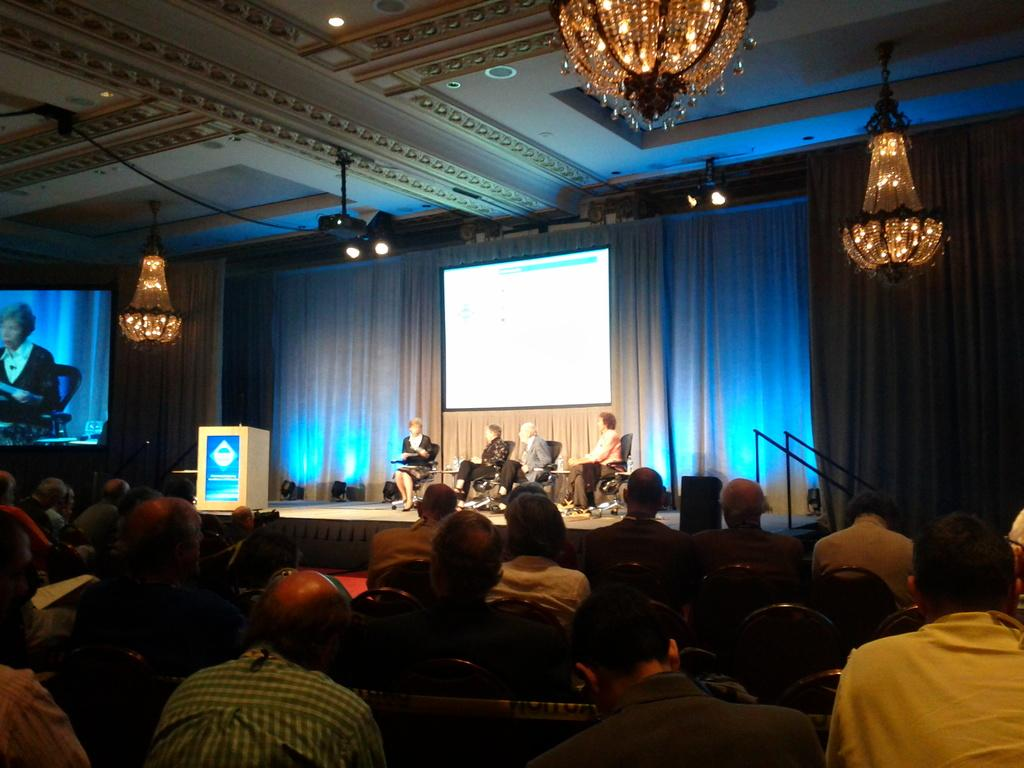How many people are in the image? There is a group of people in the image. What are some of the people doing in the image? Some people are sitting on chairs, while others are on stage. What can be seen on stage in the image? There is a podium in the image. What type of lighting is present in the image? There are lights in the image. What type of display devices are present in the image? There are screens in the image. What type of decorative element is present in the image? There is a chandelier in the image. What type of audio equipment is present in the image? There is a speaker in the image. What type of structure is present in the image? There is a roof in the image. How many quarters are visible on the chairs in the image? There are no quarters visible on the chairs in the image. Can you help me find the chair that is missing in the image? There is no mention of a missing chair in the image, and all chairs appear to be present. 